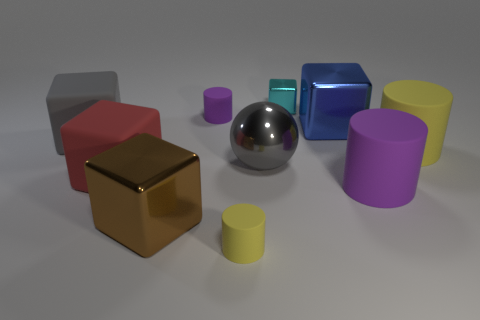How many yellow cylinders must be subtracted to get 1 yellow cylinders? 1 Subtract all spheres. How many objects are left? 9 Subtract 5 cubes. How many cubes are left? 0 Subtract all gray blocks. Subtract all gray spheres. How many blocks are left? 4 Subtract all yellow balls. How many yellow cylinders are left? 2 Subtract all brown metal objects. Subtract all big red cubes. How many objects are left? 8 Add 2 tiny yellow things. How many tiny yellow things are left? 3 Add 7 purple matte blocks. How many purple matte blocks exist? 7 Subtract all yellow cylinders. How many cylinders are left? 2 Subtract all tiny purple cylinders. How many cylinders are left? 3 